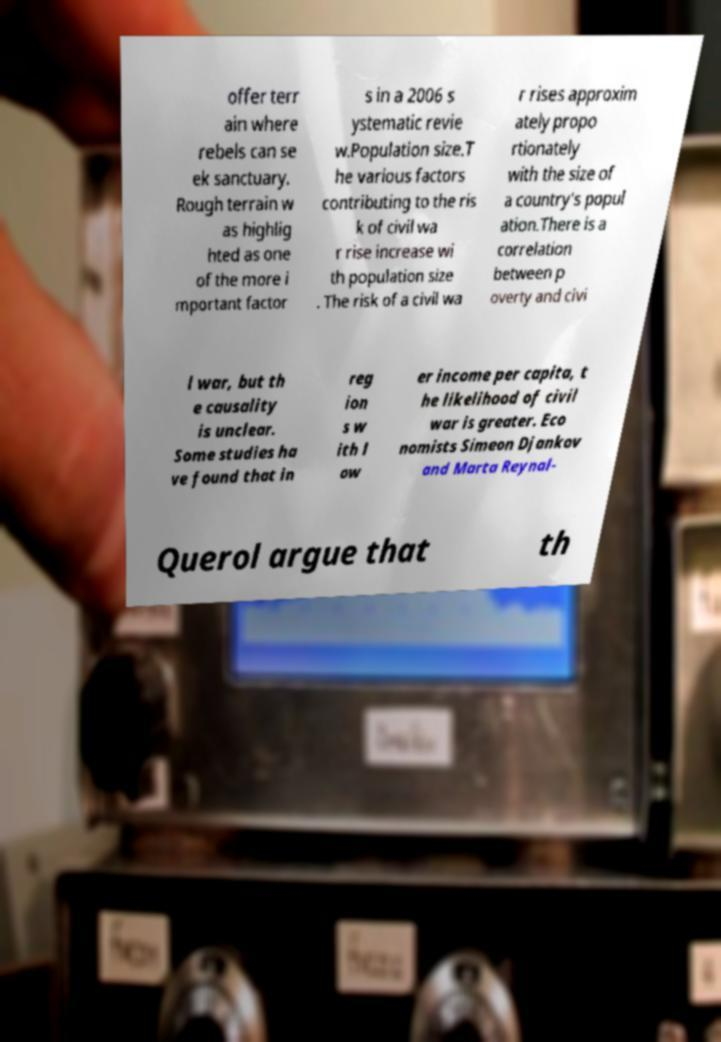Could you extract and type out the text from this image? offer terr ain where rebels can se ek sanctuary. Rough terrain w as highlig hted as one of the more i mportant factor s in a 2006 s ystematic revie w.Population size.T he various factors contributing to the ris k of civil wa r rise increase wi th population size . The risk of a civil wa r rises approxim ately propo rtionately with the size of a country's popul ation.There is a correlation between p overty and civi l war, but th e causality is unclear. Some studies ha ve found that in reg ion s w ith l ow er income per capita, t he likelihood of civil war is greater. Eco nomists Simeon Djankov and Marta Reynal- Querol argue that th 